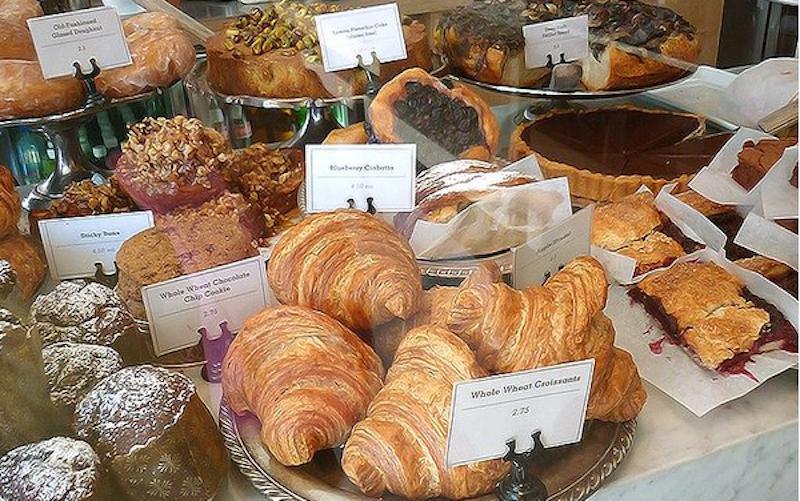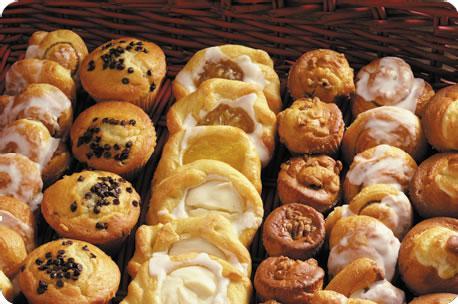The first image is the image on the left, the second image is the image on the right. Assess this claim about the two images: "One image shows individual stands holding cards in front of bakery items laid out on counter.". Correct or not? Answer yes or no. Yes. The first image is the image on the left, the second image is the image on the right. Considering the images on both sides, is "The pastries in the right image are labeled, and the ones in the left image are not." valid? Answer yes or no. No. 